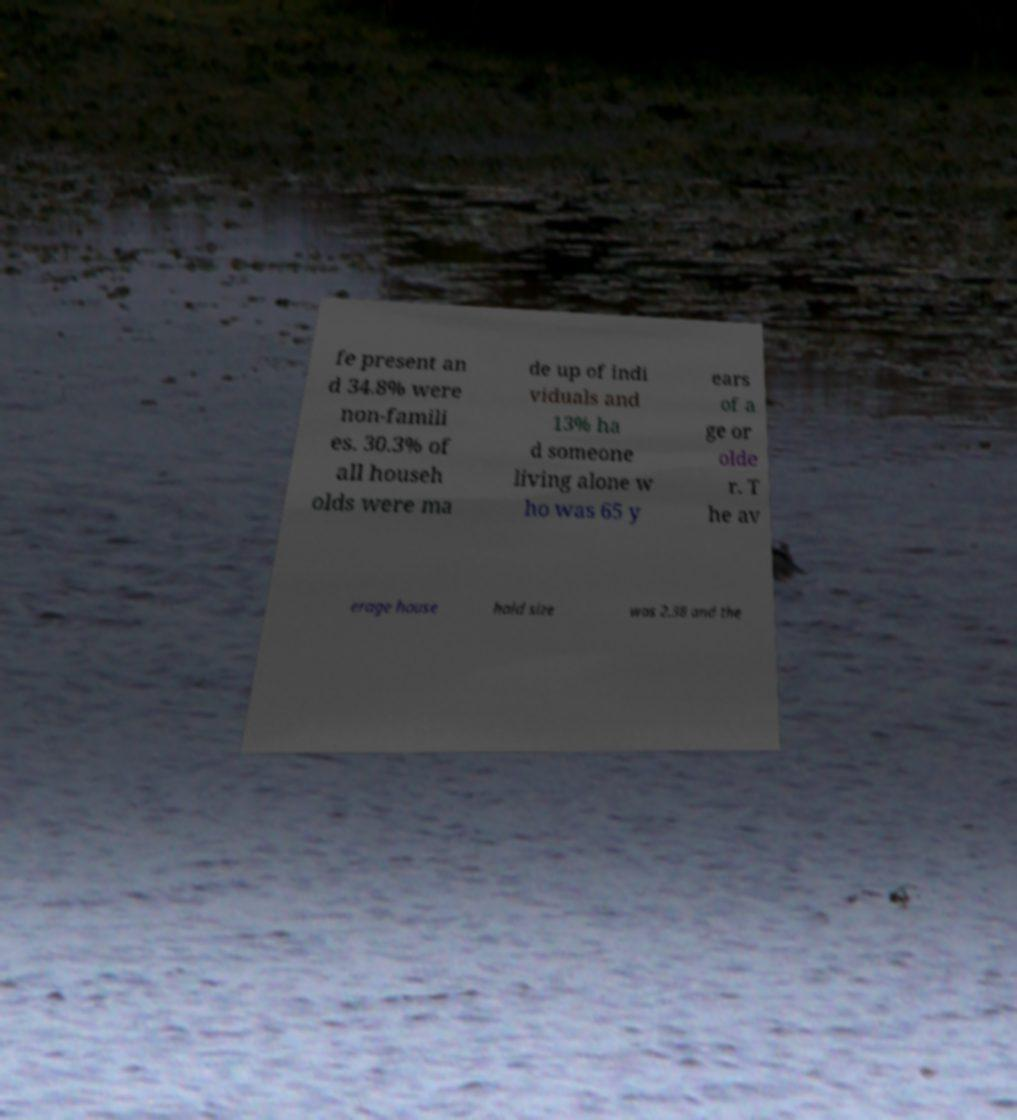Please read and relay the text visible in this image. What does it say? fe present an d 34.8% were non-famili es. 30.3% of all househ olds were ma de up of indi viduals and 13% ha d someone living alone w ho was 65 y ears of a ge or olde r. T he av erage house hold size was 2.38 and the 